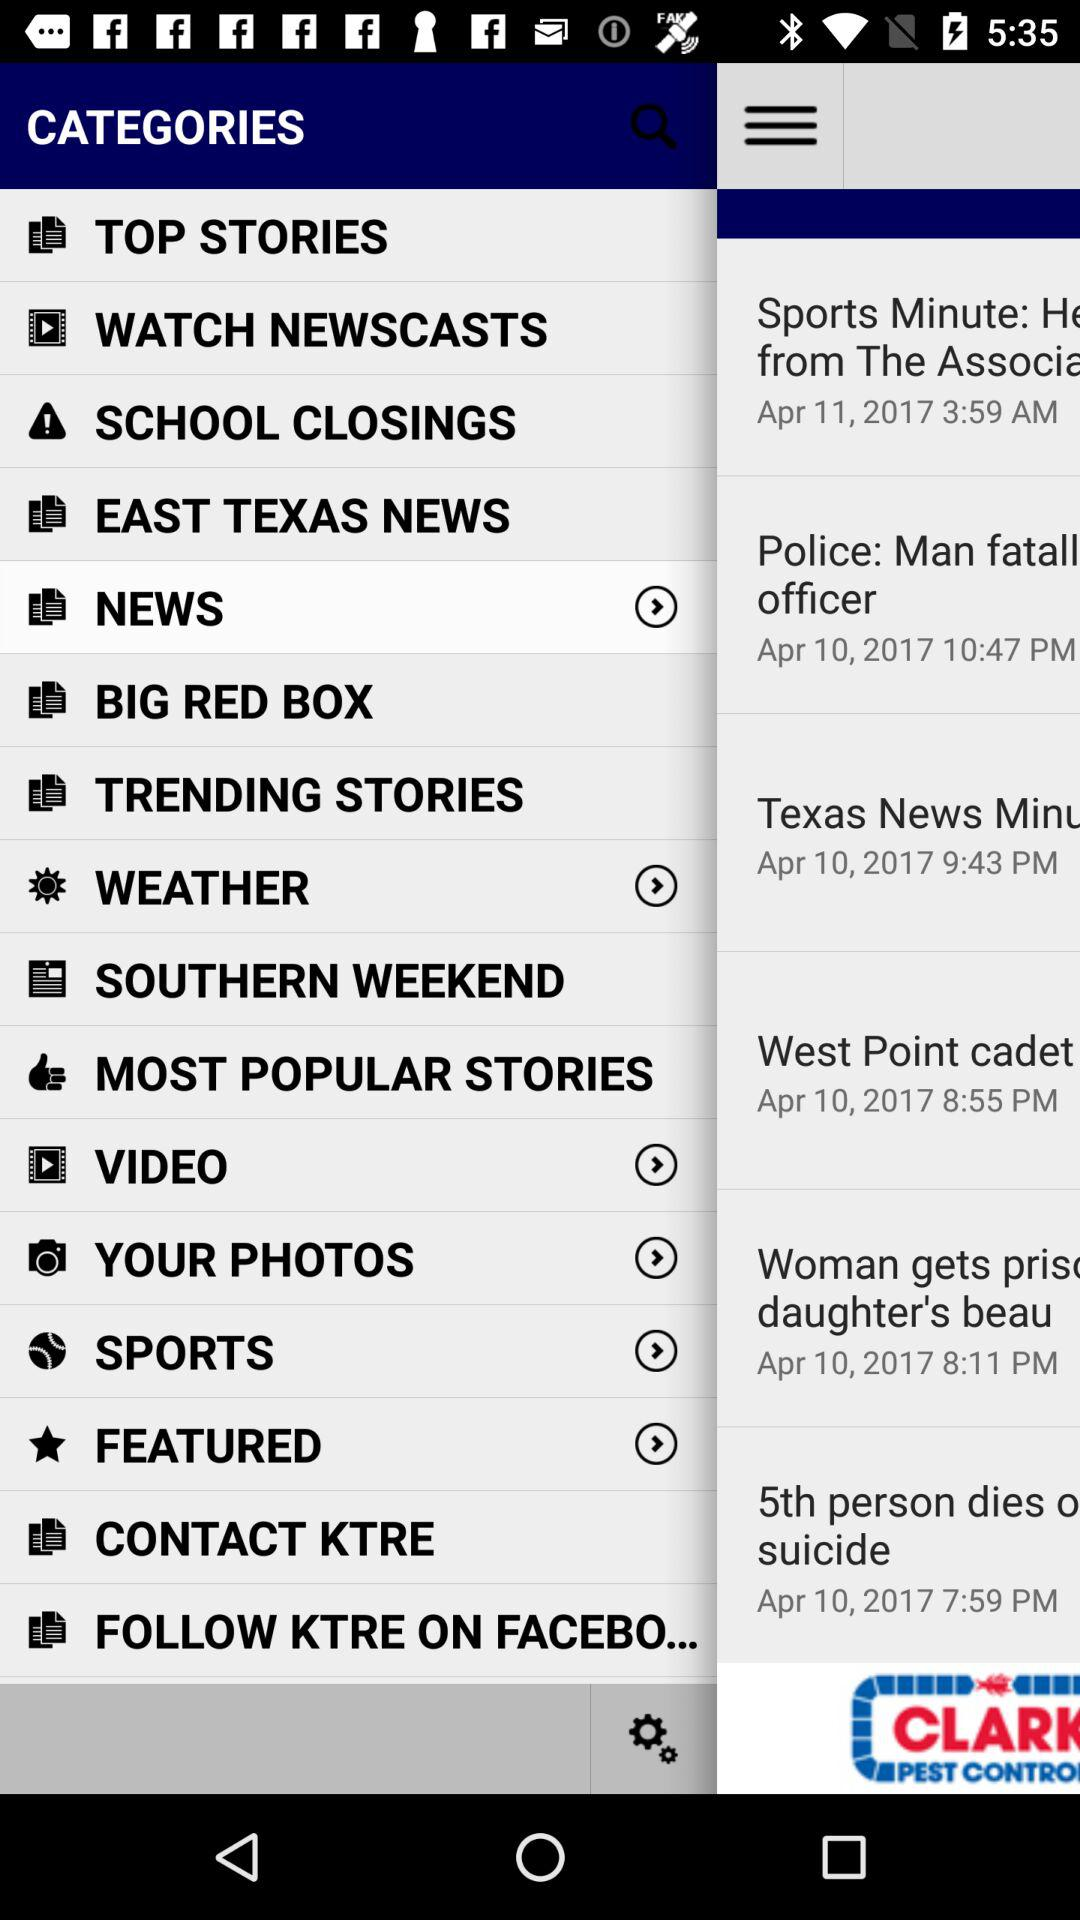What is the selected category? The selected category is "NEWS". 